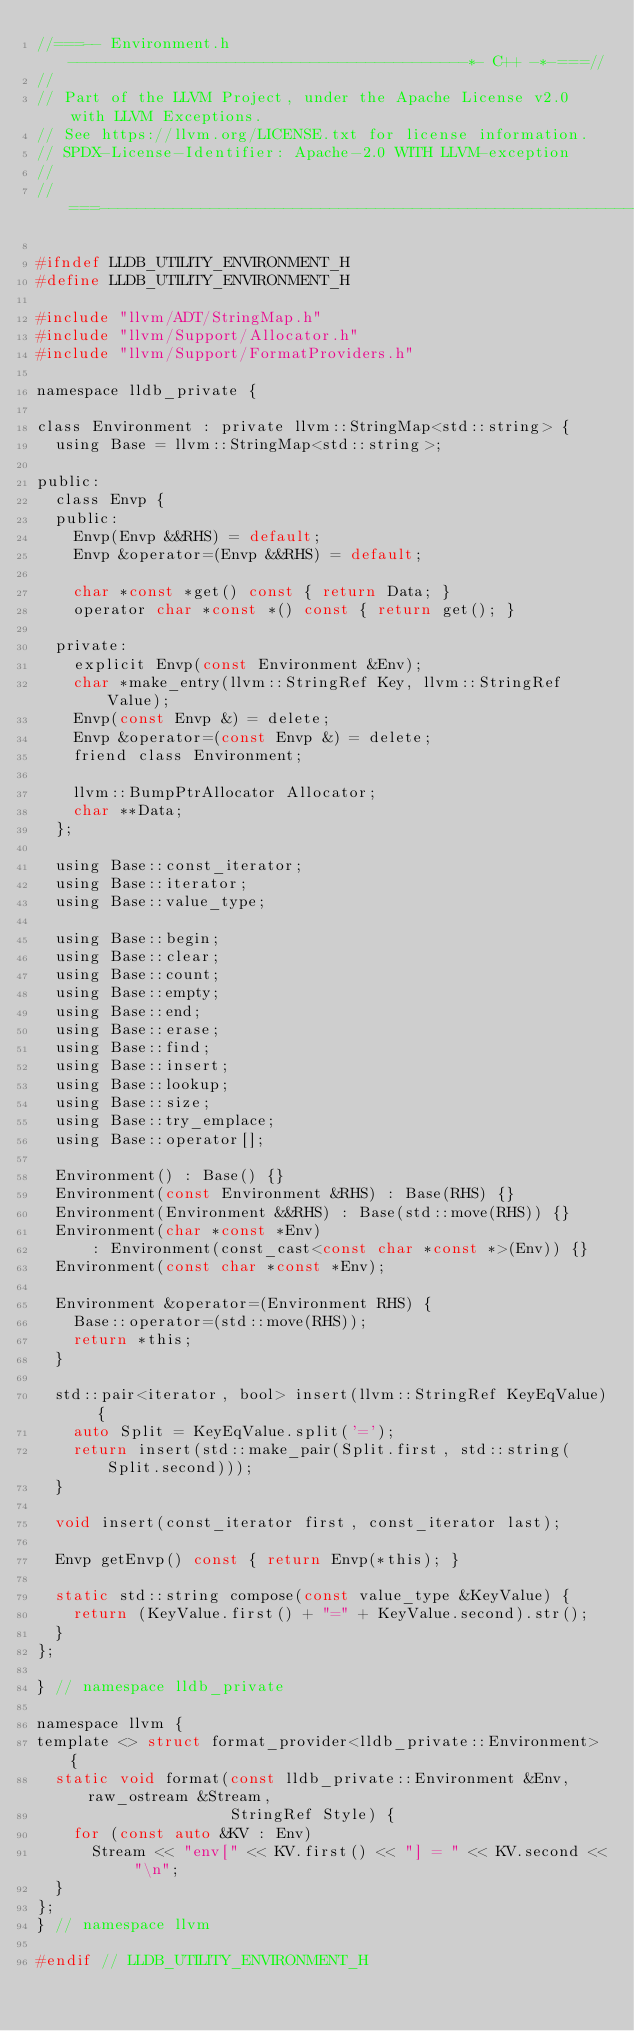<code> <loc_0><loc_0><loc_500><loc_500><_C_>//===-- Environment.h -------------------------------------------*- C++ -*-===//
//
// Part of the LLVM Project, under the Apache License v2.0 with LLVM Exceptions.
// See https://llvm.org/LICENSE.txt for license information.
// SPDX-License-Identifier: Apache-2.0 WITH LLVM-exception
//
//===----------------------------------------------------------------------===//

#ifndef LLDB_UTILITY_ENVIRONMENT_H
#define LLDB_UTILITY_ENVIRONMENT_H

#include "llvm/ADT/StringMap.h"
#include "llvm/Support/Allocator.h"
#include "llvm/Support/FormatProviders.h"

namespace lldb_private {

class Environment : private llvm::StringMap<std::string> {
  using Base = llvm::StringMap<std::string>;

public:
  class Envp {
  public:
    Envp(Envp &&RHS) = default;
    Envp &operator=(Envp &&RHS) = default;

    char *const *get() const { return Data; }
    operator char *const *() const { return get(); }

  private:
    explicit Envp(const Environment &Env);
    char *make_entry(llvm::StringRef Key, llvm::StringRef Value);
    Envp(const Envp &) = delete;
    Envp &operator=(const Envp &) = delete;
    friend class Environment;

    llvm::BumpPtrAllocator Allocator;
    char **Data;
  };

  using Base::const_iterator;
  using Base::iterator;
  using Base::value_type;

  using Base::begin;
  using Base::clear;
  using Base::count;
  using Base::empty;
  using Base::end;
  using Base::erase;
  using Base::find;
  using Base::insert;
  using Base::lookup;
  using Base::size;
  using Base::try_emplace;
  using Base::operator[];

  Environment() : Base() {}
  Environment(const Environment &RHS) : Base(RHS) {}
  Environment(Environment &&RHS) : Base(std::move(RHS)) {}
  Environment(char *const *Env)
      : Environment(const_cast<const char *const *>(Env)) {}
  Environment(const char *const *Env);

  Environment &operator=(Environment RHS) {
    Base::operator=(std::move(RHS));
    return *this;
  }

  std::pair<iterator, bool> insert(llvm::StringRef KeyEqValue) {
    auto Split = KeyEqValue.split('=');
    return insert(std::make_pair(Split.first, std::string(Split.second)));
  }

  void insert(const_iterator first, const_iterator last);

  Envp getEnvp() const { return Envp(*this); }

  static std::string compose(const value_type &KeyValue) {
    return (KeyValue.first() + "=" + KeyValue.second).str();
  }
};

} // namespace lldb_private

namespace llvm {
template <> struct format_provider<lldb_private::Environment> {
  static void format(const lldb_private::Environment &Env, raw_ostream &Stream,
                     StringRef Style) {
    for (const auto &KV : Env)
      Stream << "env[" << KV.first() << "] = " << KV.second << "\n";
  }
};
} // namespace llvm

#endif // LLDB_UTILITY_ENVIRONMENT_H
</code> 